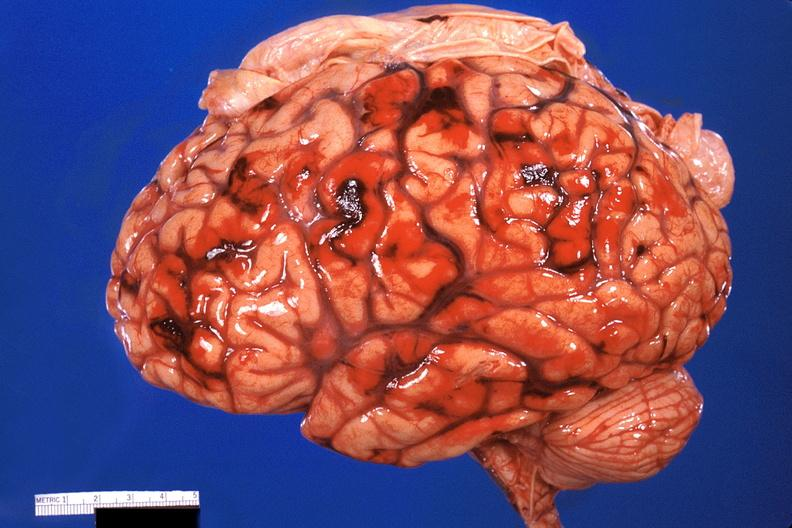what does this image show?
Answer the question using a single word or phrase. Brain 